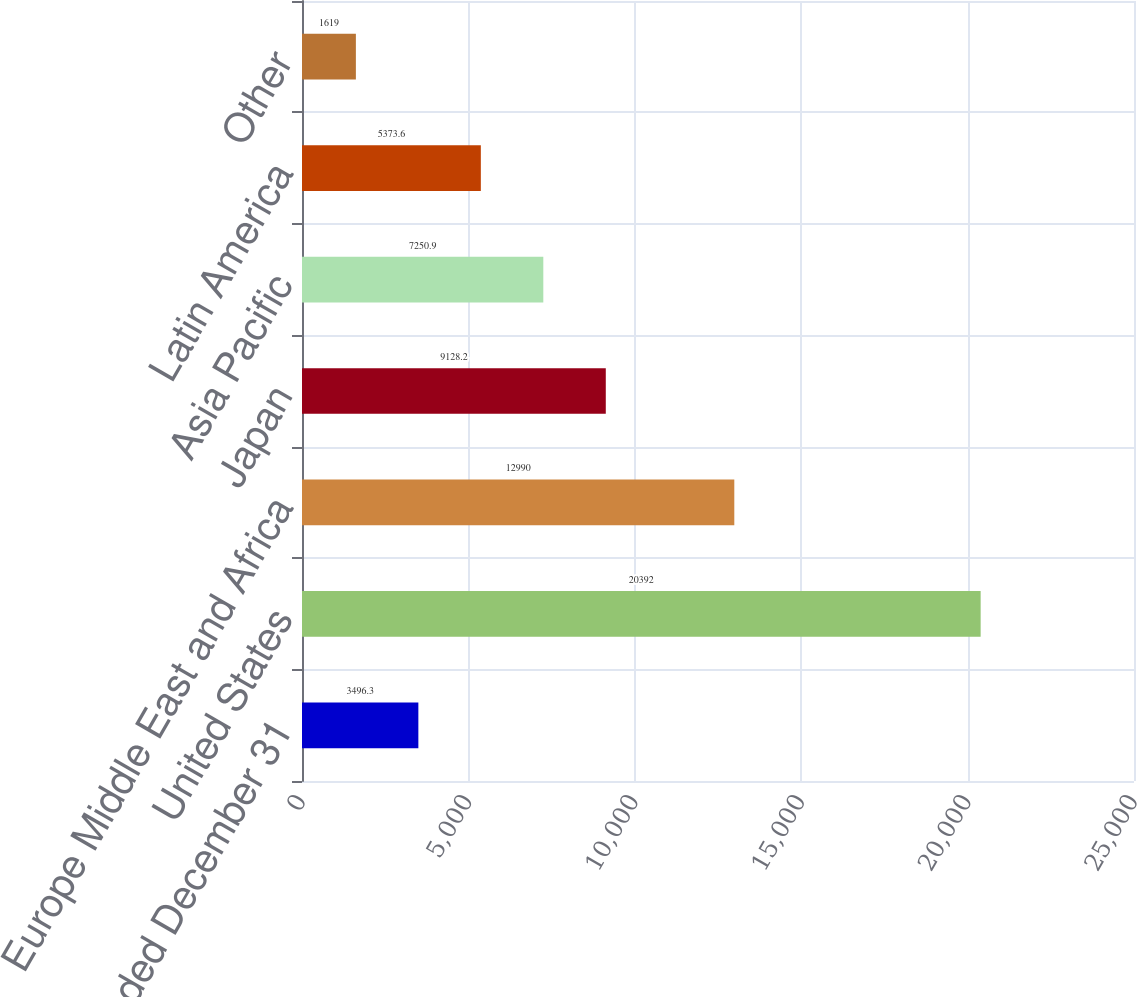<chart> <loc_0><loc_0><loc_500><loc_500><bar_chart><fcel>Years Ended December 31<fcel>United States<fcel>Europe Middle East and Africa<fcel>Japan<fcel>Asia Pacific<fcel>Latin America<fcel>Other<nl><fcel>3496.3<fcel>20392<fcel>12990<fcel>9128.2<fcel>7250.9<fcel>5373.6<fcel>1619<nl></chart> 